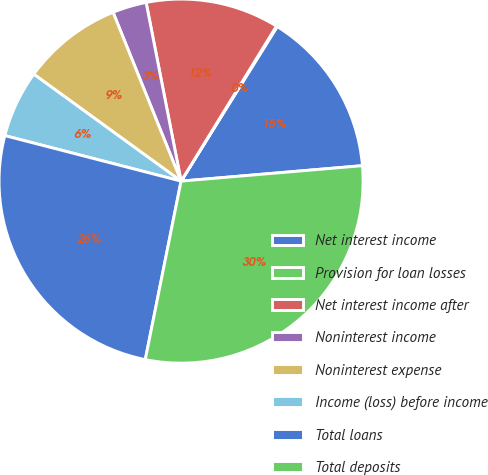<chart> <loc_0><loc_0><loc_500><loc_500><pie_chart><fcel>Net interest income<fcel>Provision for loan losses<fcel>Net interest income after<fcel>Noninterest income<fcel>Noninterest expense<fcel>Income (loss) before income<fcel>Total loans<fcel>Total deposits<nl><fcel>14.79%<fcel>0.08%<fcel>11.85%<fcel>3.02%<fcel>8.91%<fcel>5.97%<fcel>25.87%<fcel>29.5%<nl></chart> 